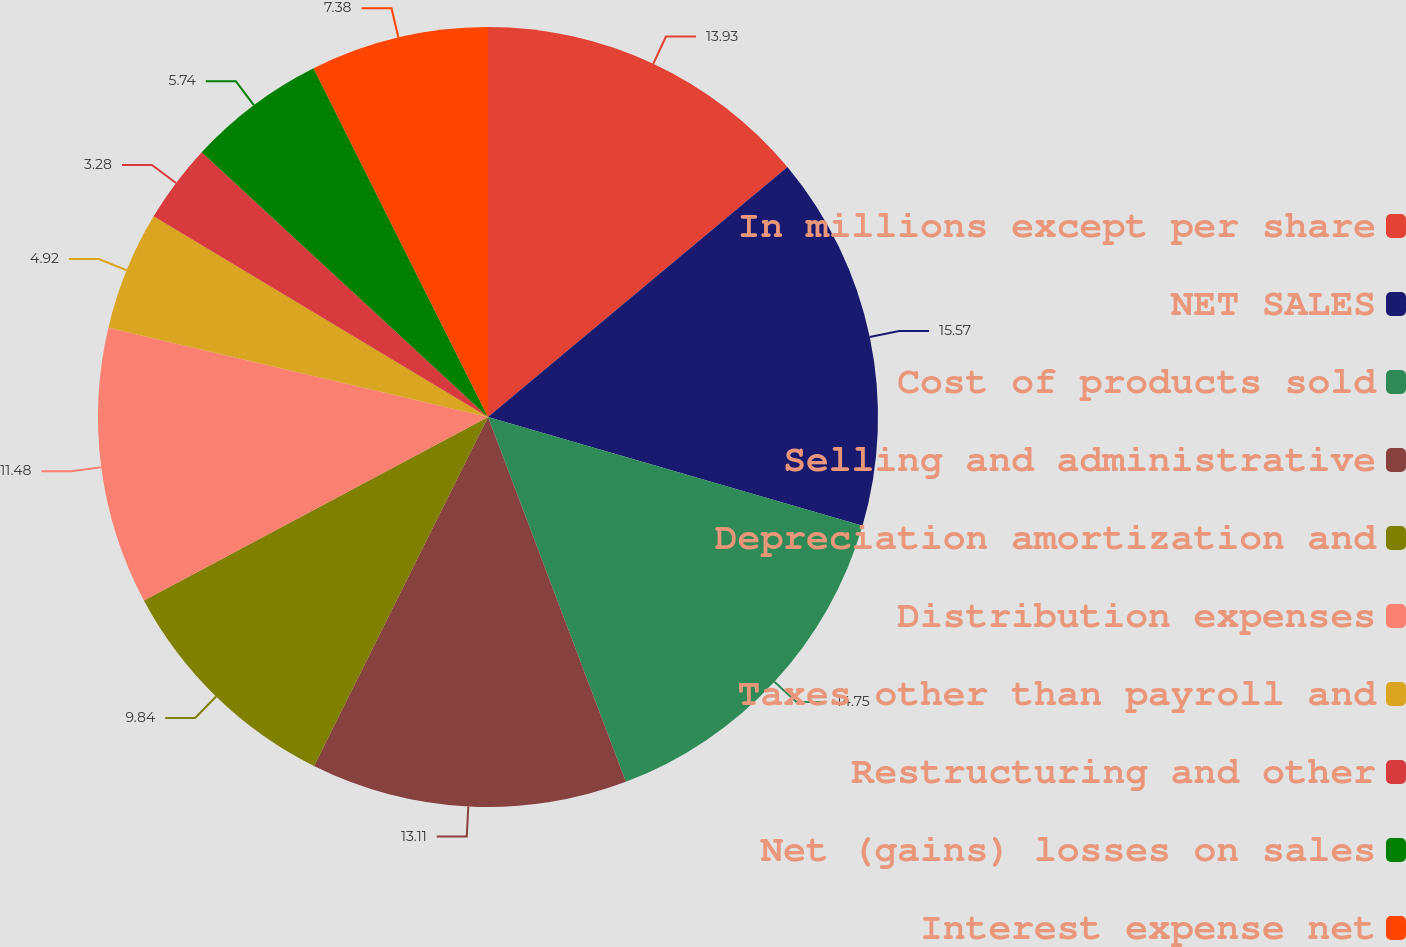<chart> <loc_0><loc_0><loc_500><loc_500><pie_chart><fcel>In millions except per share<fcel>NET SALES<fcel>Cost of products sold<fcel>Selling and administrative<fcel>Depreciation amortization and<fcel>Distribution expenses<fcel>Taxes other than payroll and<fcel>Restructuring and other<fcel>Net (gains) losses on sales<fcel>Interest expense net<nl><fcel>13.93%<fcel>15.57%<fcel>14.75%<fcel>13.11%<fcel>9.84%<fcel>11.48%<fcel>4.92%<fcel>3.28%<fcel>5.74%<fcel>7.38%<nl></chart> 